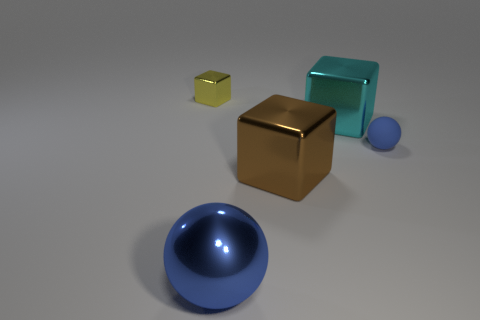Is there any other thing that has the same shape as the small yellow shiny object?
Provide a short and direct response. Yes. How many big metal cubes are there?
Keep it short and to the point. 2. What number of blue objects are blocks or large shiny things?
Provide a succinct answer. 1. Does the large cube behind the brown shiny block have the same material as the big brown object?
Ensure brevity in your answer.  Yes. How many other things are there of the same material as the yellow thing?
Ensure brevity in your answer.  3. What is the material of the small yellow object?
Provide a succinct answer. Metal. There is a cyan cube behind the tiny blue matte object; what size is it?
Make the answer very short. Large. There is a blue sphere in front of the tiny sphere; what number of objects are to the left of it?
Offer a terse response. 1. Do the thing that is left of the blue metallic object and the small object that is on the right side of the small yellow thing have the same shape?
Make the answer very short. No. How many shiny objects are behind the small rubber sphere and to the right of the big blue metallic ball?
Provide a succinct answer. 1. 